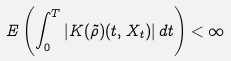<formula> <loc_0><loc_0><loc_500><loc_500>E \left ( \int _ { 0 } ^ { T } | K ( \tilde { \rho } ) ( t , X _ { t } ) | \, d t \right ) < \infty</formula> 